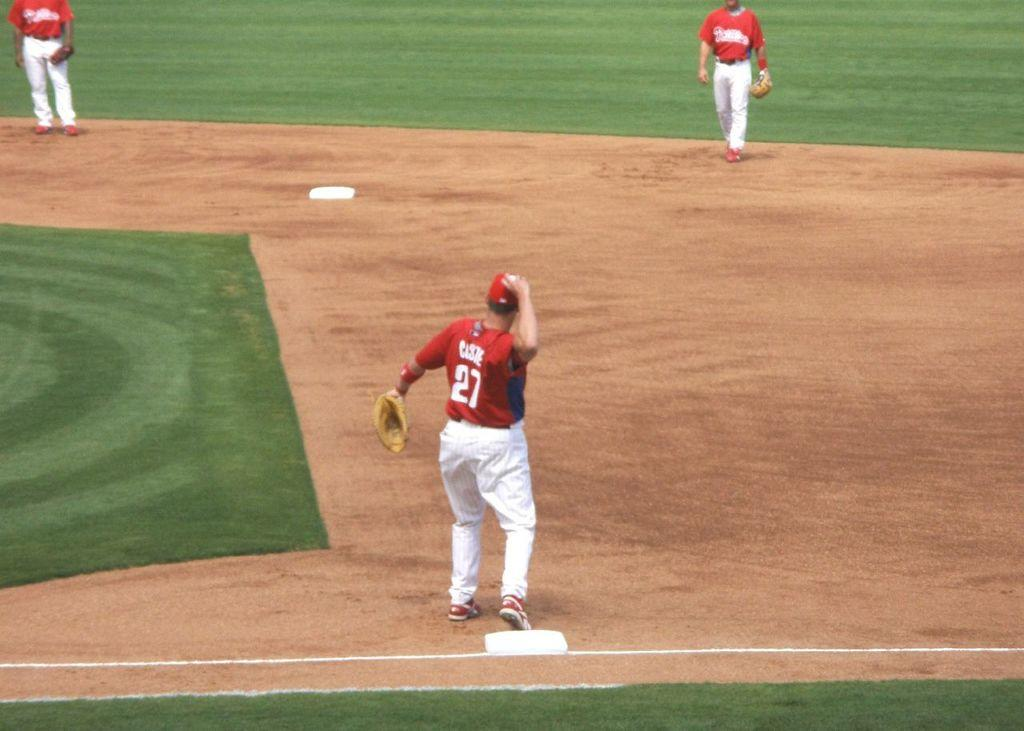<image>
Provide a brief description of the given image. The first baseman who wears the number 27 gets ready to throw a baseball. 